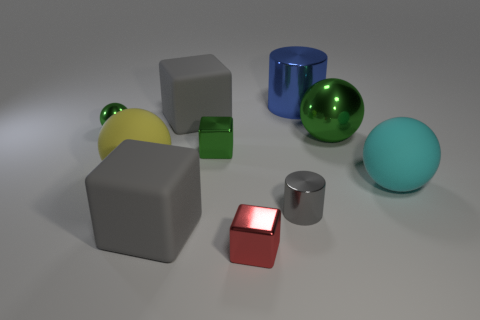What size is the gray metal object that is the same shape as the big blue metal object?
Offer a very short reply. Small. There is a large gray object that is behind the shiny ball on the right side of the gray metal cylinder; what is its shape?
Your answer should be compact. Cube. What number of red things are matte blocks or balls?
Give a very brief answer. 0. What color is the big shiny sphere?
Your answer should be compact. Green. Does the cyan ball have the same size as the blue thing?
Provide a short and direct response. Yes. Is there anything else that is the same shape as the big green thing?
Provide a short and direct response. Yes. Is the material of the small gray thing the same as the green object to the right of the large metal cylinder?
Ensure brevity in your answer.  Yes. There is a big block in front of the cyan rubber object; is it the same color as the small metallic cylinder?
Your answer should be compact. Yes. What number of gray matte things are behind the big green sphere and in front of the yellow rubber ball?
Your answer should be very brief. 0. How many other things are made of the same material as the yellow ball?
Provide a short and direct response. 3. 